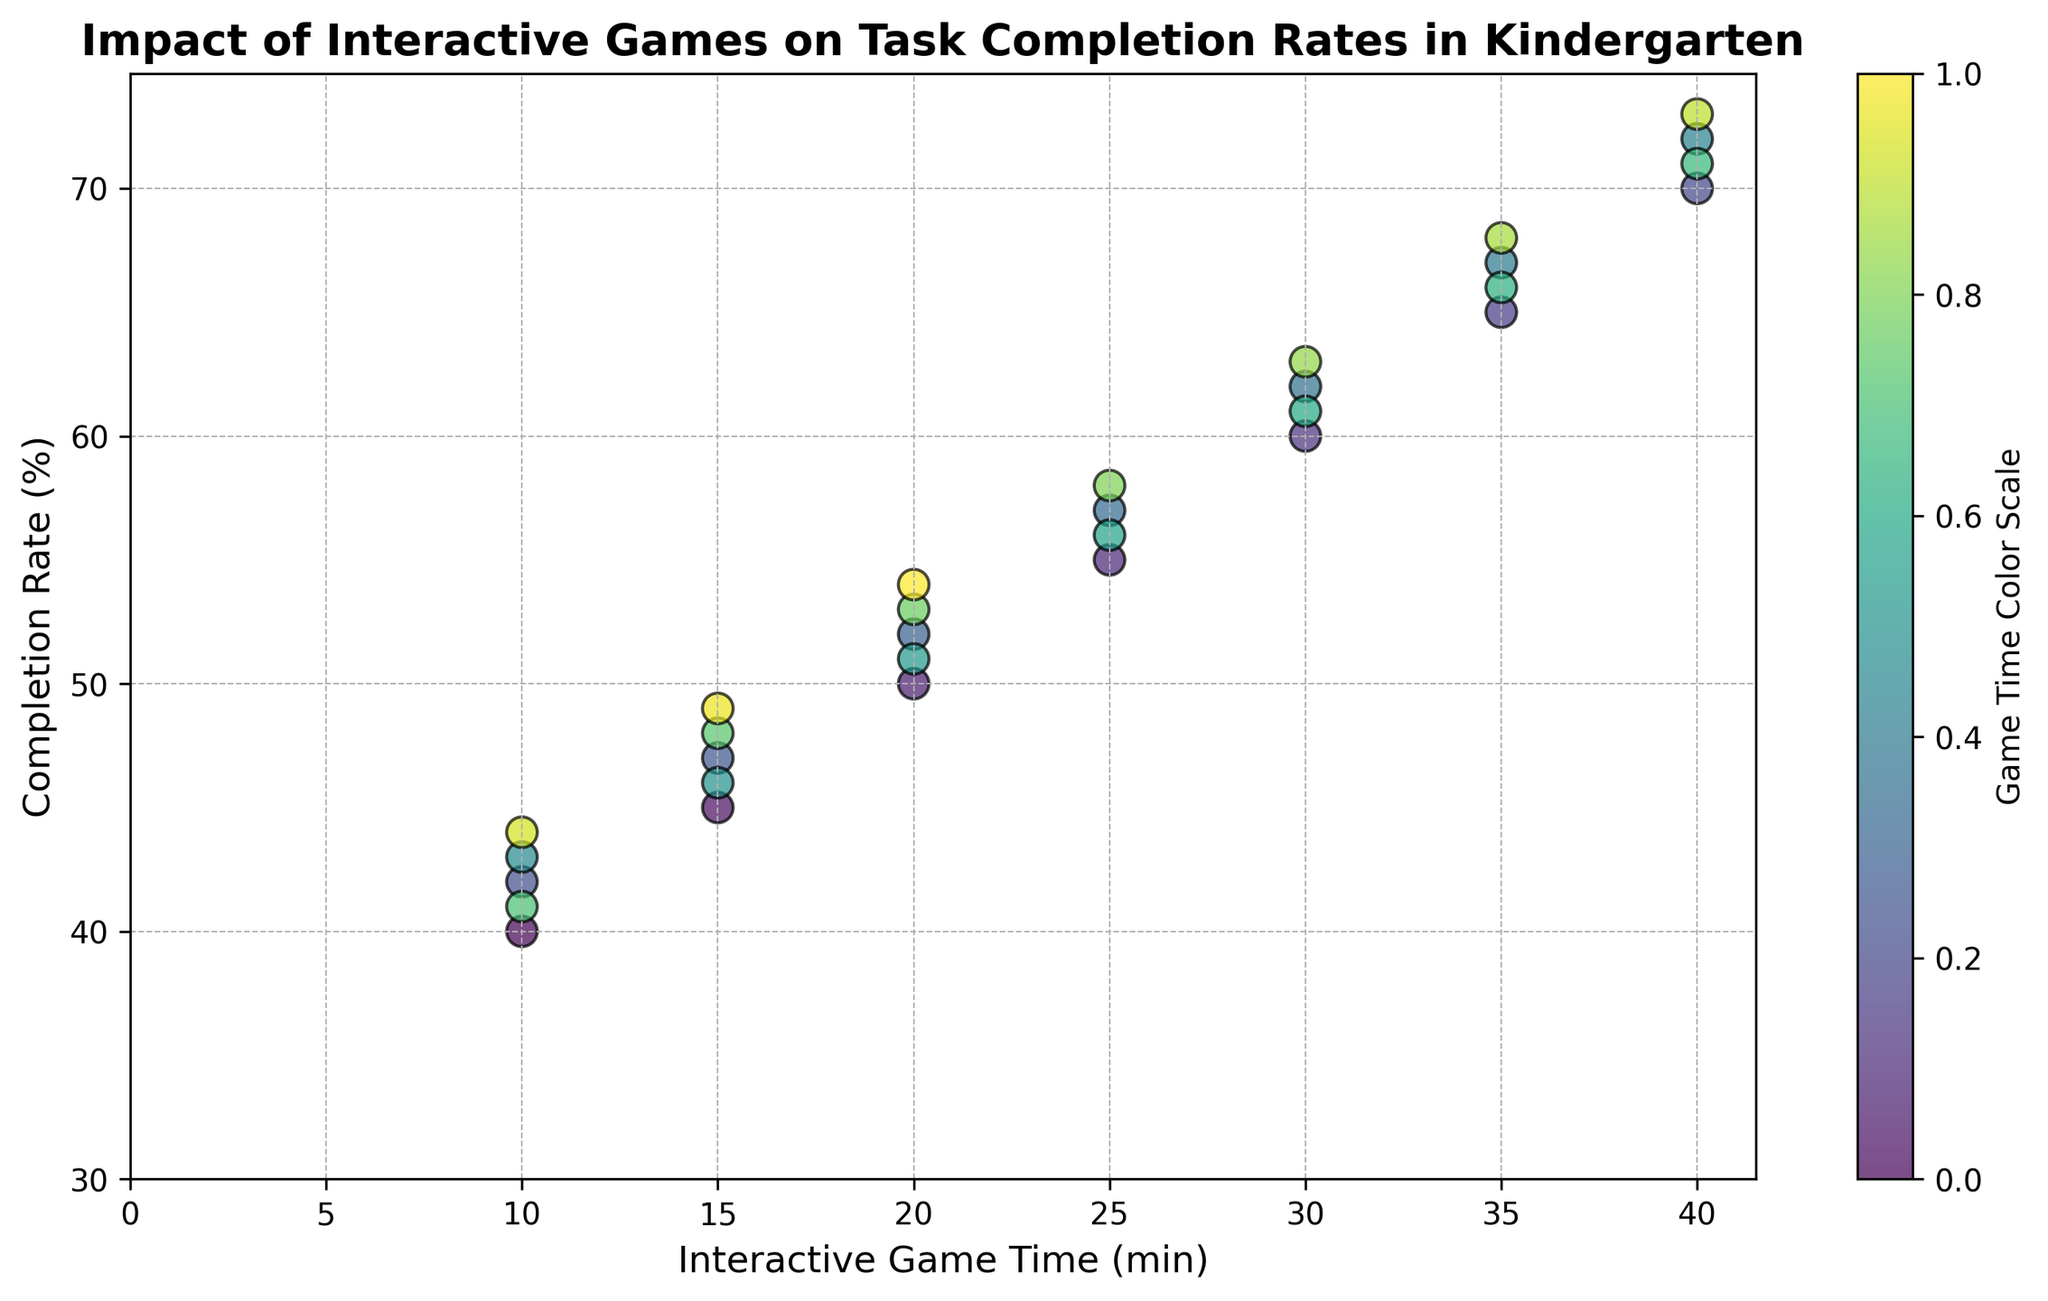What's the average completion rate when interactive game time is 20 minutes? There are four data points with 20 minutes of interactive game time. The completion rates are 50%, 52%, 51%, and 54%. Adding these up gives (50 + 52 + 51 + 54) = 207. Dividing by the number of data points, 207 / 4 = 51.75
Answer: 51.75% What is the general trend between interactive game time and task completion rate? As the interactive game time increases, the completion rate also tends to increase. This can be observed through the upward trend of the scatter plot points from left to right.
Answer: Positive trend Which day had the highest task completion rate, and what was the interactive game time on that day? The highest task completion rate is 73%, which corresponds to an interactive game time of 40 minutes on January 28, 2023.
Answer: January 28, 40 minutes What is the completion rate when the interactive game time is at its lowest? The lowest interactive game time is 10 minutes, and the completion rates for these instances are 40%, 42%, 43%, 41%, and 44%. The lowest completion rate among these is 40%.
Answer: 40% How does the completion rate change from 15 minutes to 35 minutes of interactive game time? By observing the points, the completion rate increases as follows: from 45% (15 minutes) to 65% (35 minutes) in one set of data points and from 46% to 66% in another. This suggests an increase of about 20 percentage points overall for the respective time frames.
Answer: Increase by approximately 20% Is there any overlap in completion rates between different interactive game times? Yes, there is an overlap. For instance, at 25 minutes of game time, completion rates are 55%, 57%, and 56%. Similarly, these completion rates can be found with other game times as well.
Answer: Yes Which range of interactive game times has the most variation in completion rates? The range of interactive game times from 10 to 15 minutes shows a variation in completion rates from 40% to 49%, which indicates more variability compared to other ranges.
Answer: 10-15 minutes What is the approximate difference in completion rates between 30 and 40 minutes of interactive game time? For 30-minute game time, the rates range around 60-63%. For 40 minutes, the rates are around 70-73%. The difference averages to about 10 percentage points.
Answer: About 10% Does an increase in interactive game time always lead to a higher completion rate? Generally, yes, but there may be small fluctuations. The overall trend shows higher completion rates with more interactive game time. However, specific days may show minor decreases or plateaus.
Answer: Generally yes, with minor fluctuations What color on the scatter plot corresponds to the maximum interactive game time? The maximum interactive game time is 40 minutes, which corresponds to the highest value on the color scale in the scatter plot. This usually represents the deepest color, possibly dark green or blue on a viridis colormap.
Answer: Deepest color on scale 